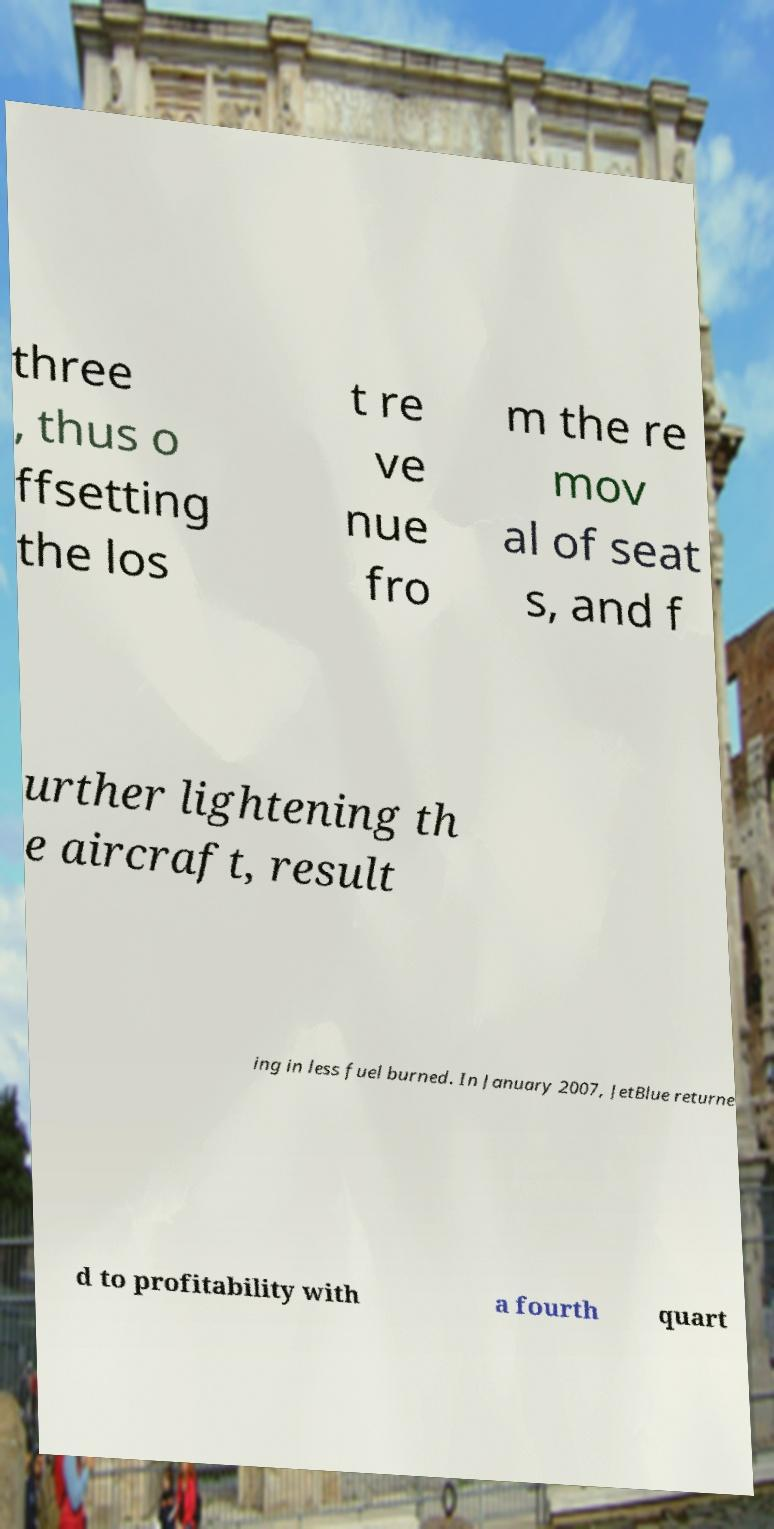What messages or text are displayed in this image? I need them in a readable, typed format. three , thus o ffsetting the los t re ve nue fro m the re mov al of seat s, and f urther lightening th e aircraft, result ing in less fuel burned. In January 2007, JetBlue returne d to profitability with a fourth quart 